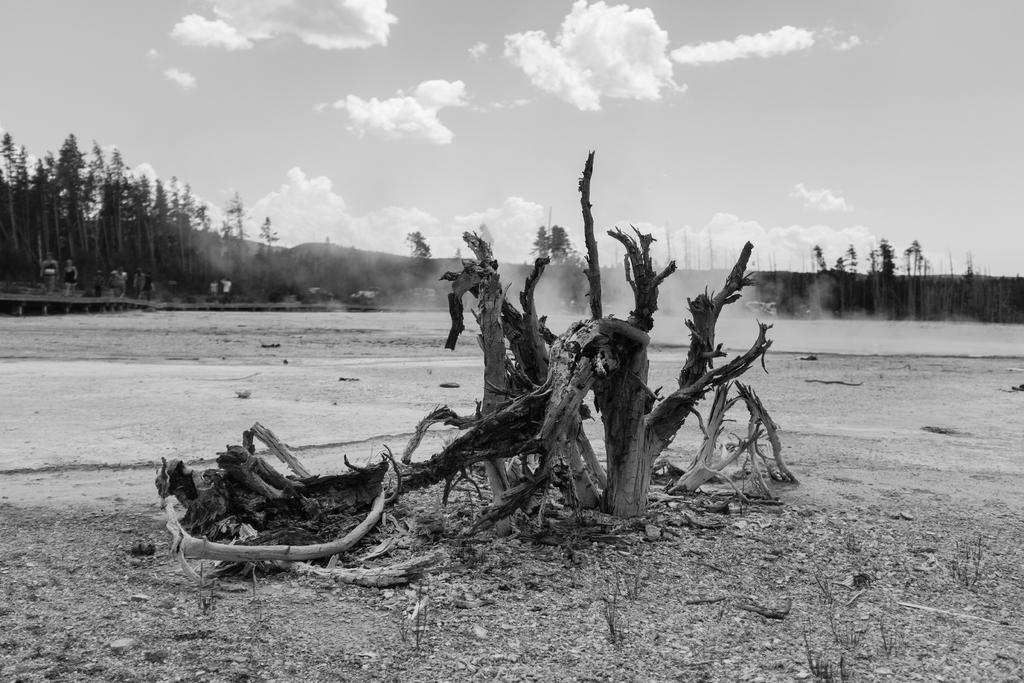What is the color scheme of the image? The image is in black and white. What is the main subject in the center of the image? There is a tree trunk in the center of the image. What can be seen in the background of the image? There are trees and the sky visible in the background of the image. Where are the people located in the image? The people are towards the left side of the image. What type of quince is being used to shock the people in the image? There is no quince or shocking activity present in the image. What question are the people asking each other in the image? There is no conversation or questioning activity depicted in the image. 